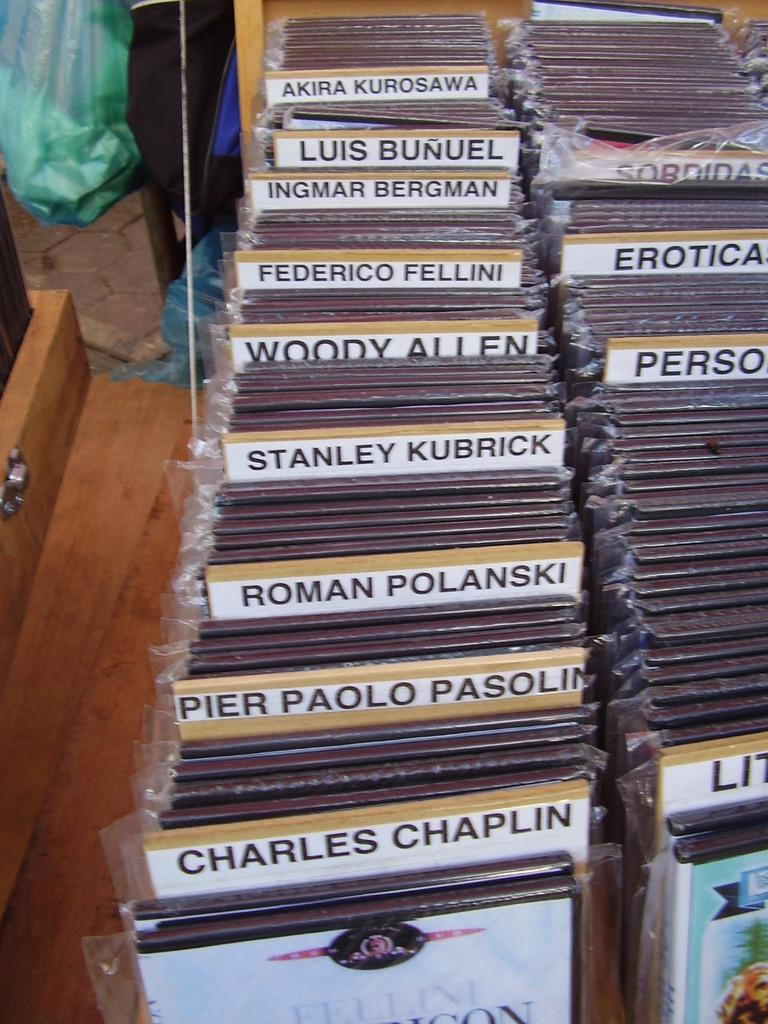Provide a one-sentence caption for the provided image. A large collection of DVDs from the likes of Woody Allen, Roman Polanski, Ingmar Bergman, and Charles Chaplin. 